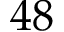<formula> <loc_0><loc_0><loc_500><loc_500>4 8</formula> 